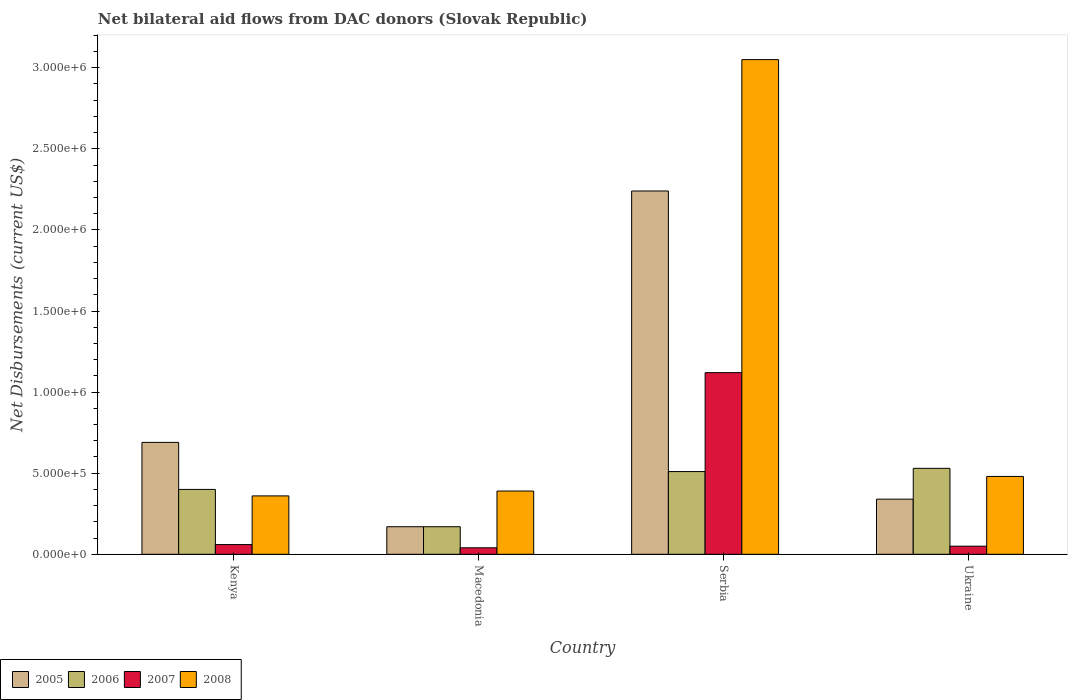How many different coloured bars are there?
Provide a short and direct response. 4. How many groups of bars are there?
Keep it short and to the point. 4. Are the number of bars per tick equal to the number of legend labels?
Keep it short and to the point. Yes. Are the number of bars on each tick of the X-axis equal?
Ensure brevity in your answer.  Yes. How many bars are there on the 4th tick from the left?
Provide a succinct answer. 4. How many bars are there on the 1st tick from the right?
Give a very brief answer. 4. What is the label of the 3rd group of bars from the left?
Offer a very short reply. Serbia. In how many cases, is the number of bars for a given country not equal to the number of legend labels?
Your answer should be compact. 0. What is the net bilateral aid flows in 2008 in Kenya?
Give a very brief answer. 3.60e+05. Across all countries, what is the maximum net bilateral aid flows in 2005?
Your answer should be compact. 2.24e+06. Across all countries, what is the minimum net bilateral aid flows in 2005?
Your answer should be compact. 1.70e+05. In which country was the net bilateral aid flows in 2005 maximum?
Provide a succinct answer. Serbia. In which country was the net bilateral aid flows in 2008 minimum?
Make the answer very short. Kenya. What is the total net bilateral aid flows in 2005 in the graph?
Your answer should be compact. 3.44e+06. What is the difference between the net bilateral aid flows in 2005 in Kenya and that in Macedonia?
Your answer should be very brief. 5.20e+05. What is the average net bilateral aid flows in 2008 per country?
Give a very brief answer. 1.07e+06. In how many countries, is the net bilateral aid flows in 2007 greater than 100000 US$?
Make the answer very short. 1. What is the ratio of the net bilateral aid flows in 2008 in Macedonia to that in Serbia?
Your answer should be very brief. 0.13. Is the net bilateral aid flows in 2008 in Kenya less than that in Serbia?
Ensure brevity in your answer.  Yes. Is the difference between the net bilateral aid flows in 2007 in Macedonia and Ukraine greater than the difference between the net bilateral aid flows in 2006 in Macedonia and Ukraine?
Offer a terse response. Yes. What is the difference between the highest and the second highest net bilateral aid flows in 2007?
Make the answer very short. 1.07e+06. What is the difference between the highest and the lowest net bilateral aid flows in 2008?
Keep it short and to the point. 2.69e+06. In how many countries, is the net bilateral aid flows in 2005 greater than the average net bilateral aid flows in 2005 taken over all countries?
Give a very brief answer. 1. Is it the case that in every country, the sum of the net bilateral aid flows in 2006 and net bilateral aid flows in 2005 is greater than the sum of net bilateral aid flows in 2008 and net bilateral aid flows in 2007?
Your answer should be very brief. No. What does the 2nd bar from the left in Serbia represents?
Offer a very short reply. 2006. Are all the bars in the graph horizontal?
Give a very brief answer. No. Are the values on the major ticks of Y-axis written in scientific E-notation?
Keep it short and to the point. Yes. Does the graph contain any zero values?
Provide a succinct answer. No. Does the graph contain grids?
Keep it short and to the point. No. How many legend labels are there?
Your response must be concise. 4. What is the title of the graph?
Your answer should be compact. Net bilateral aid flows from DAC donors (Slovak Republic). What is the label or title of the Y-axis?
Make the answer very short. Net Disbursements (current US$). What is the Net Disbursements (current US$) of 2005 in Kenya?
Make the answer very short. 6.90e+05. What is the Net Disbursements (current US$) in 2006 in Kenya?
Provide a succinct answer. 4.00e+05. What is the Net Disbursements (current US$) of 2007 in Kenya?
Your response must be concise. 6.00e+04. What is the Net Disbursements (current US$) in 2008 in Kenya?
Your answer should be very brief. 3.60e+05. What is the Net Disbursements (current US$) in 2005 in Serbia?
Your response must be concise. 2.24e+06. What is the Net Disbursements (current US$) in 2006 in Serbia?
Provide a short and direct response. 5.10e+05. What is the Net Disbursements (current US$) in 2007 in Serbia?
Keep it short and to the point. 1.12e+06. What is the Net Disbursements (current US$) of 2008 in Serbia?
Provide a succinct answer. 3.05e+06. What is the Net Disbursements (current US$) in 2006 in Ukraine?
Your answer should be very brief. 5.30e+05. What is the Net Disbursements (current US$) in 2008 in Ukraine?
Offer a terse response. 4.80e+05. Across all countries, what is the maximum Net Disbursements (current US$) in 2005?
Your response must be concise. 2.24e+06. Across all countries, what is the maximum Net Disbursements (current US$) of 2006?
Provide a short and direct response. 5.30e+05. Across all countries, what is the maximum Net Disbursements (current US$) in 2007?
Your answer should be very brief. 1.12e+06. Across all countries, what is the maximum Net Disbursements (current US$) in 2008?
Offer a very short reply. 3.05e+06. Across all countries, what is the minimum Net Disbursements (current US$) of 2005?
Keep it short and to the point. 1.70e+05. Across all countries, what is the minimum Net Disbursements (current US$) of 2007?
Keep it short and to the point. 4.00e+04. What is the total Net Disbursements (current US$) in 2005 in the graph?
Ensure brevity in your answer.  3.44e+06. What is the total Net Disbursements (current US$) in 2006 in the graph?
Keep it short and to the point. 1.61e+06. What is the total Net Disbursements (current US$) of 2007 in the graph?
Your answer should be compact. 1.27e+06. What is the total Net Disbursements (current US$) of 2008 in the graph?
Offer a very short reply. 4.28e+06. What is the difference between the Net Disbursements (current US$) of 2005 in Kenya and that in Macedonia?
Keep it short and to the point. 5.20e+05. What is the difference between the Net Disbursements (current US$) of 2006 in Kenya and that in Macedonia?
Offer a very short reply. 2.30e+05. What is the difference between the Net Disbursements (current US$) of 2008 in Kenya and that in Macedonia?
Offer a very short reply. -3.00e+04. What is the difference between the Net Disbursements (current US$) of 2005 in Kenya and that in Serbia?
Your response must be concise. -1.55e+06. What is the difference between the Net Disbursements (current US$) in 2006 in Kenya and that in Serbia?
Provide a succinct answer. -1.10e+05. What is the difference between the Net Disbursements (current US$) in 2007 in Kenya and that in Serbia?
Keep it short and to the point. -1.06e+06. What is the difference between the Net Disbursements (current US$) of 2008 in Kenya and that in Serbia?
Offer a very short reply. -2.69e+06. What is the difference between the Net Disbursements (current US$) in 2006 in Kenya and that in Ukraine?
Your answer should be compact. -1.30e+05. What is the difference between the Net Disbursements (current US$) in 2005 in Macedonia and that in Serbia?
Give a very brief answer. -2.07e+06. What is the difference between the Net Disbursements (current US$) in 2006 in Macedonia and that in Serbia?
Your answer should be very brief. -3.40e+05. What is the difference between the Net Disbursements (current US$) of 2007 in Macedonia and that in Serbia?
Offer a very short reply. -1.08e+06. What is the difference between the Net Disbursements (current US$) in 2008 in Macedonia and that in Serbia?
Provide a succinct answer. -2.66e+06. What is the difference between the Net Disbursements (current US$) of 2006 in Macedonia and that in Ukraine?
Provide a succinct answer. -3.60e+05. What is the difference between the Net Disbursements (current US$) of 2005 in Serbia and that in Ukraine?
Make the answer very short. 1.90e+06. What is the difference between the Net Disbursements (current US$) of 2006 in Serbia and that in Ukraine?
Offer a terse response. -2.00e+04. What is the difference between the Net Disbursements (current US$) in 2007 in Serbia and that in Ukraine?
Your response must be concise. 1.07e+06. What is the difference between the Net Disbursements (current US$) in 2008 in Serbia and that in Ukraine?
Provide a short and direct response. 2.57e+06. What is the difference between the Net Disbursements (current US$) in 2005 in Kenya and the Net Disbursements (current US$) in 2006 in Macedonia?
Offer a very short reply. 5.20e+05. What is the difference between the Net Disbursements (current US$) in 2005 in Kenya and the Net Disbursements (current US$) in 2007 in Macedonia?
Your answer should be very brief. 6.50e+05. What is the difference between the Net Disbursements (current US$) of 2005 in Kenya and the Net Disbursements (current US$) of 2008 in Macedonia?
Ensure brevity in your answer.  3.00e+05. What is the difference between the Net Disbursements (current US$) in 2006 in Kenya and the Net Disbursements (current US$) in 2007 in Macedonia?
Ensure brevity in your answer.  3.60e+05. What is the difference between the Net Disbursements (current US$) of 2007 in Kenya and the Net Disbursements (current US$) of 2008 in Macedonia?
Your answer should be very brief. -3.30e+05. What is the difference between the Net Disbursements (current US$) in 2005 in Kenya and the Net Disbursements (current US$) in 2007 in Serbia?
Your answer should be compact. -4.30e+05. What is the difference between the Net Disbursements (current US$) of 2005 in Kenya and the Net Disbursements (current US$) of 2008 in Serbia?
Provide a short and direct response. -2.36e+06. What is the difference between the Net Disbursements (current US$) of 2006 in Kenya and the Net Disbursements (current US$) of 2007 in Serbia?
Your answer should be very brief. -7.20e+05. What is the difference between the Net Disbursements (current US$) in 2006 in Kenya and the Net Disbursements (current US$) in 2008 in Serbia?
Keep it short and to the point. -2.65e+06. What is the difference between the Net Disbursements (current US$) of 2007 in Kenya and the Net Disbursements (current US$) of 2008 in Serbia?
Your answer should be very brief. -2.99e+06. What is the difference between the Net Disbursements (current US$) in 2005 in Kenya and the Net Disbursements (current US$) in 2007 in Ukraine?
Ensure brevity in your answer.  6.40e+05. What is the difference between the Net Disbursements (current US$) in 2005 in Kenya and the Net Disbursements (current US$) in 2008 in Ukraine?
Ensure brevity in your answer.  2.10e+05. What is the difference between the Net Disbursements (current US$) in 2006 in Kenya and the Net Disbursements (current US$) in 2008 in Ukraine?
Give a very brief answer. -8.00e+04. What is the difference between the Net Disbursements (current US$) of 2007 in Kenya and the Net Disbursements (current US$) of 2008 in Ukraine?
Ensure brevity in your answer.  -4.20e+05. What is the difference between the Net Disbursements (current US$) of 2005 in Macedonia and the Net Disbursements (current US$) of 2007 in Serbia?
Give a very brief answer. -9.50e+05. What is the difference between the Net Disbursements (current US$) of 2005 in Macedonia and the Net Disbursements (current US$) of 2008 in Serbia?
Provide a short and direct response. -2.88e+06. What is the difference between the Net Disbursements (current US$) in 2006 in Macedonia and the Net Disbursements (current US$) in 2007 in Serbia?
Offer a very short reply. -9.50e+05. What is the difference between the Net Disbursements (current US$) in 2006 in Macedonia and the Net Disbursements (current US$) in 2008 in Serbia?
Your answer should be compact. -2.88e+06. What is the difference between the Net Disbursements (current US$) in 2007 in Macedonia and the Net Disbursements (current US$) in 2008 in Serbia?
Provide a succinct answer. -3.01e+06. What is the difference between the Net Disbursements (current US$) in 2005 in Macedonia and the Net Disbursements (current US$) in 2006 in Ukraine?
Offer a very short reply. -3.60e+05. What is the difference between the Net Disbursements (current US$) of 2005 in Macedonia and the Net Disbursements (current US$) of 2007 in Ukraine?
Your response must be concise. 1.20e+05. What is the difference between the Net Disbursements (current US$) of 2005 in Macedonia and the Net Disbursements (current US$) of 2008 in Ukraine?
Offer a very short reply. -3.10e+05. What is the difference between the Net Disbursements (current US$) of 2006 in Macedonia and the Net Disbursements (current US$) of 2007 in Ukraine?
Offer a terse response. 1.20e+05. What is the difference between the Net Disbursements (current US$) in 2006 in Macedonia and the Net Disbursements (current US$) in 2008 in Ukraine?
Give a very brief answer. -3.10e+05. What is the difference between the Net Disbursements (current US$) in 2007 in Macedonia and the Net Disbursements (current US$) in 2008 in Ukraine?
Keep it short and to the point. -4.40e+05. What is the difference between the Net Disbursements (current US$) of 2005 in Serbia and the Net Disbursements (current US$) of 2006 in Ukraine?
Make the answer very short. 1.71e+06. What is the difference between the Net Disbursements (current US$) of 2005 in Serbia and the Net Disbursements (current US$) of 2007 in Ukraine?
Keep it short and to the point. 2.19e+06. What is the difference between the Net Disbursements (current US$) of 2005 in Serbia and the Net Disbursements (current US$) of 2008 in Ukraine?
Keep it short and to the point. 1.76e+06. What is the difference between the Net Disbursements (current US$) of 2007 in Serbia and the Net Disbursements (current US$) of 2008 in Ukraine?
Provide a succinct answer. 6.40e+05. What is the average Net Disbursements (current US$) in 2005 per country?
Ensure brevity in your answer.  8.60e+05. What is the average Net Disbursements (current US$) of 2006 per country?
Make the answer very short. 4.02e+05. What is the average Net Disbursements (current US$) of 2007 per country?
Give a very brief answer. 3.18e+05. What is the average Net Disbursements (current US$) in 2008 per country?
Make the answer very short. 1.07e+06. What is the difference between the Net Disbursements (current US$) of 2005 and Net Disbursements (current US$) of 2007 in Kenya?
Your response must be concise. 6.30e+05. What is the difference between the Net Disbursements (current US$) of 2005 and Net Disbursements (current US$) of 2008 in Kenya?
Give a very brief answer. 3.30e+05. What is the difference between the Net Disbursements (current US$) in 2006 and Net Disbursements (current US$) in 2007 in Kenya?
Offer a very short reply. 3.40e+05. What is the difference between the Net Disbursements (current US$) in 2007 and Net Disbursements (current US$) in 2008 in Kenya?
Ensure brevity in your answer.  -3.00e+05. What is the difference between the Net Disbursements (current US$) in 2006 and Net Disbursements (current US$) in 2008 in Macedonia?
Ensure brevity in your answer.  -2.20e+05. What is the difference between the Net Disbursements (current US$) in 2007 and Net Disbursements (current US$) in 2008 in Macedonia?
Give a very brief answer. -3.50e+05. What is the difference between the Net Disbursements (current US$) in 2005 and Net Disbursements (current US$) in 2006 in Serbia?
Offer a terse response. 1.73e+06. What is the difference between the Net Disbursements (current US$) in 2005 and Net Disbursements (current US$) in 2007 in Serbia?
Offer a terse response. 1.12e+06. What is the difference between the Net Disbursements (current US$) in 2005 and Net Disbursements (current US$) in 2008 in Serbia?
Keep it short and to the point. -8.10e+05. What is the difference between the Net Disbursements (current US$) of 2006 and Net Disbursements (current US$) of 2007 in Serbia?
Make the answer very short. -6.10e+05. What is the difference between the Net Disbursements (current US$) of 2006 and Net Disbursements (current US$) of 2008 in Serbia?
Provide a short and direct response. -2.54e+06. What is the difference between the Net Disbursements (current US$) in 2007 and Net Disbursements (current US$) in 2008 in Serbia?
Make the answer very short. -1.93e+06. What is the difference between the Net Disbursements (current US$) in 2005 and Net Disbursements (current US$) in 2007 in Ukraine?
Offer a very short reply. 2.90e+05. What is the difference between the Net Disbursements (current US$) of 2005 and Net Disbursements (current US$) of 2008 in Ukraine?
Your response must be concise. -1.40e+05. What is the difference between the Net Disbursements (current US$) of 2006 and Net Disbursements (current US$) of 2007 in Ukraine?
Make the answer very short. 4.80e+05. What is the difference between the Net Disbursements (current US$) of 2007 and Net Disbursements (current US$) of 2008 in Ukraine?
Your answer should be compact. -4.30e+05. What is the ratio of the Net Disbursements (current US$) in 2005 in Kenya to that in Macedonia?
Make the answer very short. 4.06. What is the ratio of the Net Disbursements (current US$) in 2006 in Kenya to that in Macedonia?
Your answer should be very brief. 2.35. What is the ratio of the Net Disbursements (current US$) of 2007 in Kenya to that in Macedonia?
Your answer should be compact. 1.5. What is the ratio of the Net Disbursements (current US$) in 2008 in Kenya to that in Macedonia?
Keep it short and to the point. 0.92. What is the ratio of the Net Disbursements (current US$) in 2005 in Kenya to that in Serbia?
Keep it short and to the point. 0.31. What is the ratio of the Net Disbursements (current US$) of 2006 in Kenya to that in Serbia?
Ensure brevity in your answer.  0.78. What is the ratio of the Net Disbursements (current US$) of 2007 in Kenya to that in Serbia?
Make the answer very short. 0.05. What is the ratio of the Net Disbursements (current US$) in 2008 in Kenya to that in Serbia?
Ensure brevity in your answer.  0.12. What is the ratio of the Net Disbursements (current US$) in 2005 in Kenya to that in Ukraine?
Offer a very short reply. 2.03. What is the ratio of the Net Disbursements (current US$) in 2006 in Kenya to that in Ukraine?
Provide a short and direct response. 0.75. What is the ratio of the Net Disbursements (current US$) of 2005 in Macedonia to that in Serbia?
Offer a very short reply. 0.08. What is the ratio of the Net Disbursements (current US$) in 2006 in Macedonia to that in Serbia?
Offer a terse response. 0.33. What is the ratio of the Net Disbursements (current US$) of 2007 in Macedonia to that in Serbia?
Make the answer very short. 0.04. What is the ratio of the Net Disbursements (current US$) in 2008 in Macedonia to that in Serbia?
Offer a very short reply. 0.13. What is the ratio of the Net Disbursements (current US$) in 2005 in Macedonia to that in Ukraine?
Your answer should be very brief. 0.5. What is the ratio of the Net Disbursements (current US$) of 2006 in Macedonia to that in Ukraine?
Give a very brief answer. 0.32. What is the ratio of the Net Disbursements (current US$) of 2008 in Macedonia to that in Ukraine?
Your answer should be very brief. 0.81. What is the ratio of the Net Disbursements (current US$) in 2005 in Serbia to that in Ukraine?
Make the answer very short. 6.59. What is the ratio of the Net Disbursements (current US$) of 2006 in Serbia to that in Ukraine?
Offer a terse response. 0.96. What is the ratio of the Net Disbursements (current US$) in 2007 in Serbia to that in Ukraine?
Your response must be concise. 22.4. What is the ratio of the Net Disbursements (current US$) of 2008 in Serbia to that in Ukraine?
Offer a terse response. 6.35. What is the difference between the highest and the second highest Net Disbursements (current US$) in 2005?
Your answer should be compact. 1.55e+06. What is the difference between the highest and the second highest Net Disbursements (current US$) in 2006?
Keep it short and to the point. 2.00e+04. What is the difference between the highest and the second highest Net Disbursements (current US$) of 2007?
Your answer should be compact. 1.06e+06. What is the difference between the highest and the second highest Net Disbursements (current US$) in 2008?
Offer a very short reply. 2.57e+06. What is the difference between the highest and the lowest Net Disbursements (current US$) in 2005?
Keep it short and to the point. 2.07e+06. What is the difference between the highest and the lowest Net Disbursements (current US$) in 2007?
Your answer should be very brief. 1.08e+06. What is the difference between the highest and the lowest Net Disbursements (current US$) in 2008?
Make the answer very short. 2.69e+06. 